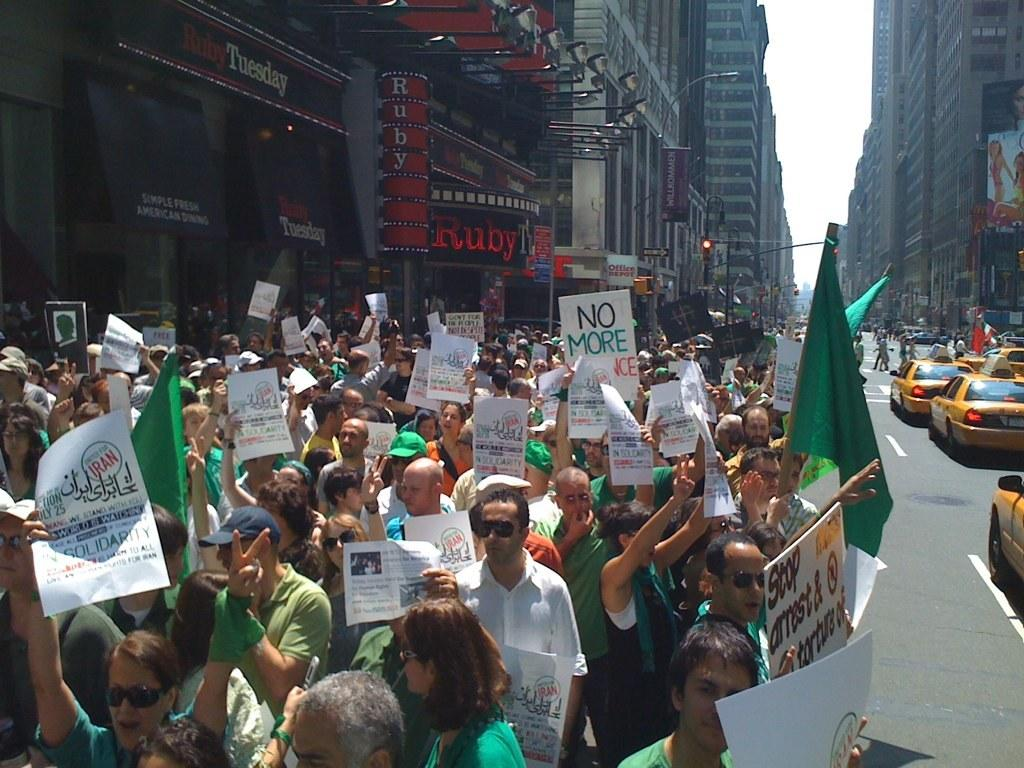<image>
Relay a brief, clear account of the picture shown. Many protestors are on a city street, and one of their signs reads "No More." 